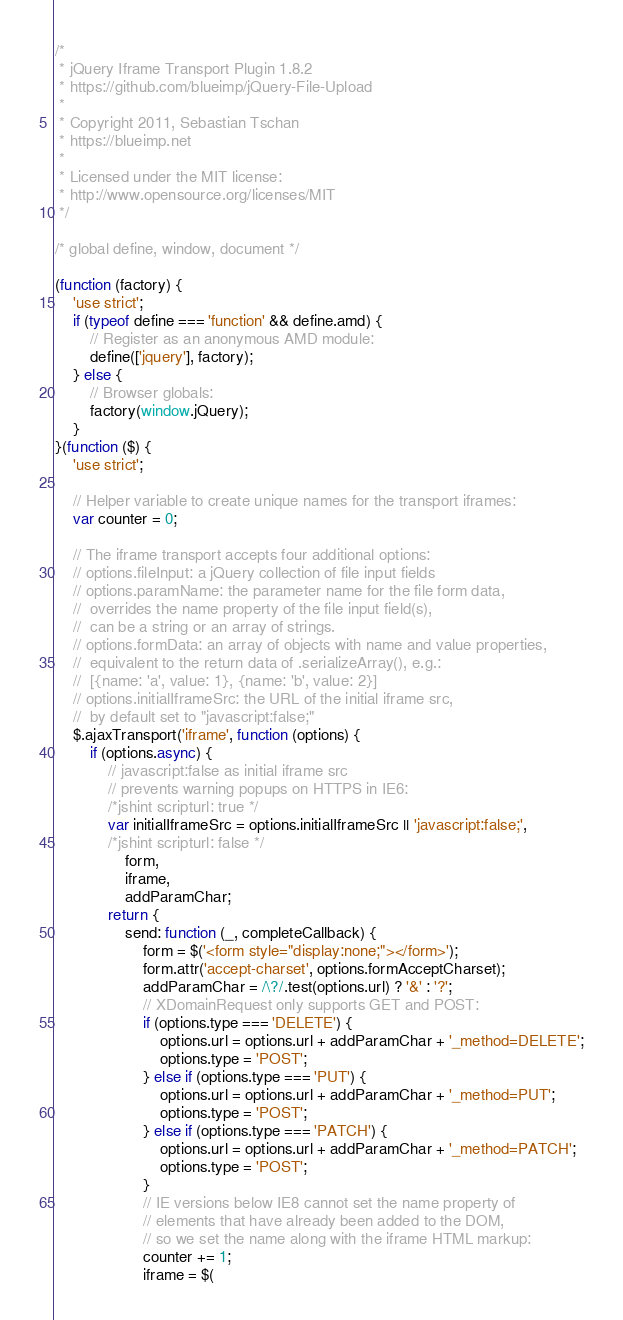<code> <loc_0><loc_0><loc_500><loc_500><_JavaScript_>/*
 * jQuery Iframe Transport Plugin 1.8.2
 * https://github.com/blueimp/jQuery-File-Upload
 *
 * Copyright 2011, Sebastian Tschan
 * https://blueimp.net
 *
 * Licensed under the MIT license:
 * http://www.opensource.org/licenses/MIT
 */

/* global define, window, document */

(function (factory) {
    'use strict';
    if (typeof define === 'function' && define.amd) {
        // Register as an anonymous AMD module:
        define(['jquery'], factory);
    } else {
        // Browser globals:
        factory(window.jQuery);
    }
}(function ($) {
    'use strict';

    // Helper variable to create unique names for the transport iframes:
    var counter = 0;

    // The iframe transport accepts four additional options:
    // options.fileInput: a jQuery collection of file input fields
    // options.paramName: the parameter name for the file form data,
    //  overrides the name property of the file input field(s),
    //  can be a string or an array of strings.
    // options.formData: an array of objects with name and value properties,
    //  equivalent to the return data of .serializeArray(), e.g.:
    //  [{name: 'a', value: 1}, {name: 'b', value: 2}]
    // options.initialIframeSrc: the URL of the initial iframe src,
    //  by default set to "javascript:false;"
    $.ajaxTransport('iframe', function (options) {
        if (options.async) {
            // javascript:false as initial iframe src
            // prevents warning popups on HTTPS in IE6:
            /*jshint scripturl: true */
            var initialIframeSrc = options.initialIframeSrc || 'javascript:false;',
            /*jshint scripturl: false */
                form,
                iframe,
                addParamChar;
            return {
                send: function (_, completeCallback) {
                    form = $('<form style="display:none;"></form>');
                    form.attr('accept-charset', options.formAcceptCharset);
                    addParamChar = /\?/.test(options.url) ? '&' : '?';
                    // XDomainRequest only supports GET and POST:
                    if (options.type === 'DELETE') {
                        options.url = options.url + addParamChar + '_method=DELETE';
                        options.type = 'POST';
                    } else if (options.type === 'PUT') {
                        options.url = options.url + addParamChar + '_method=PUT';
                        options.type = 'POST';
                    } else if (options.type === 'PATCH') {
                        options.url = options.url + addParamChar + '_method=PATCH';
                        options.type = 'POST';
                    }
                    // IE versions below IE8 cannot set the name property of
                    // elements that have already been added to the DOM,
                    // so we set the name along with the iframe HTML markup:
                    counter += 1;
                    iframe = $(</code> 